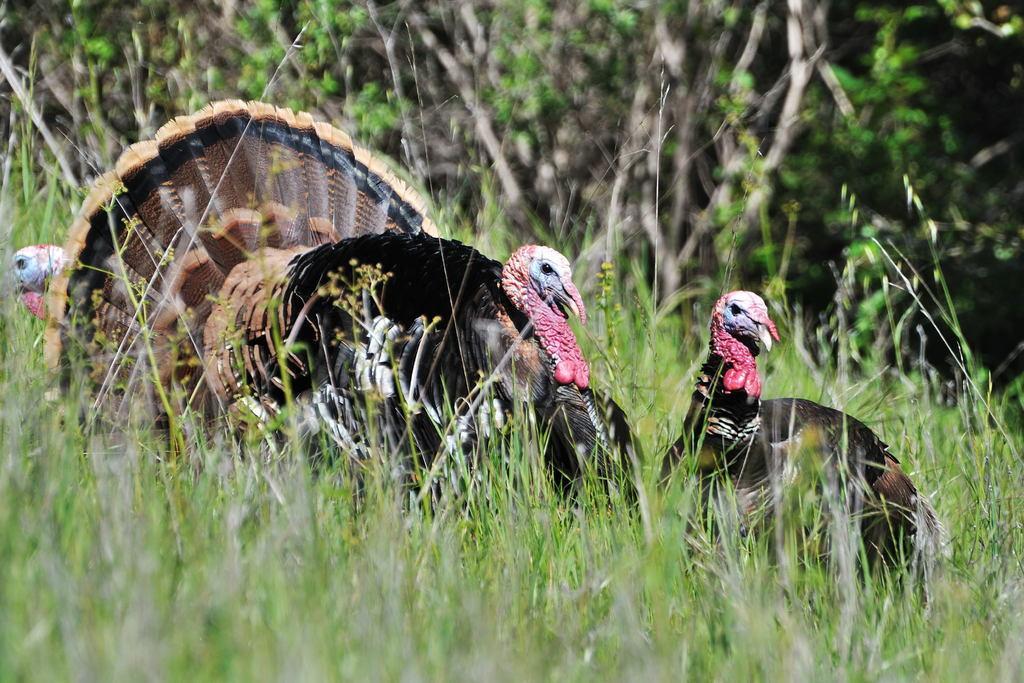Can you describe this image briefly? At the bottom we can see grass and there are birds and an object on the ground. In the background there are plants. 